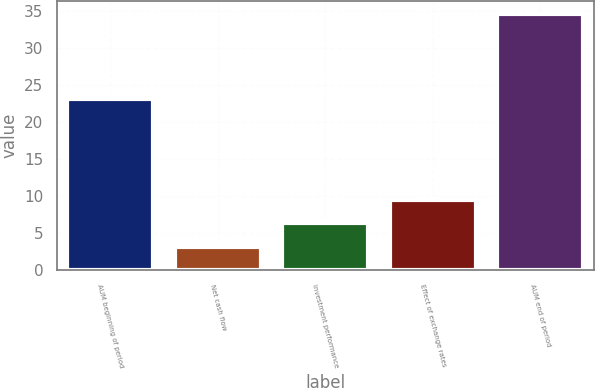Convert chart to OTSL. <chart><loc_0><loc_0><loc_500><loc_500><bar_chart><fcel>AUM beginning of period<fcel>Net cash flow<fcel>Investment performance<fcel>Effect of exchange rates<fcel>AUM end of period<nl><fcel>23.1<fcel>3.2<fcel>6.34<fcel>9.48<fcel>34.6<nl></chart> 